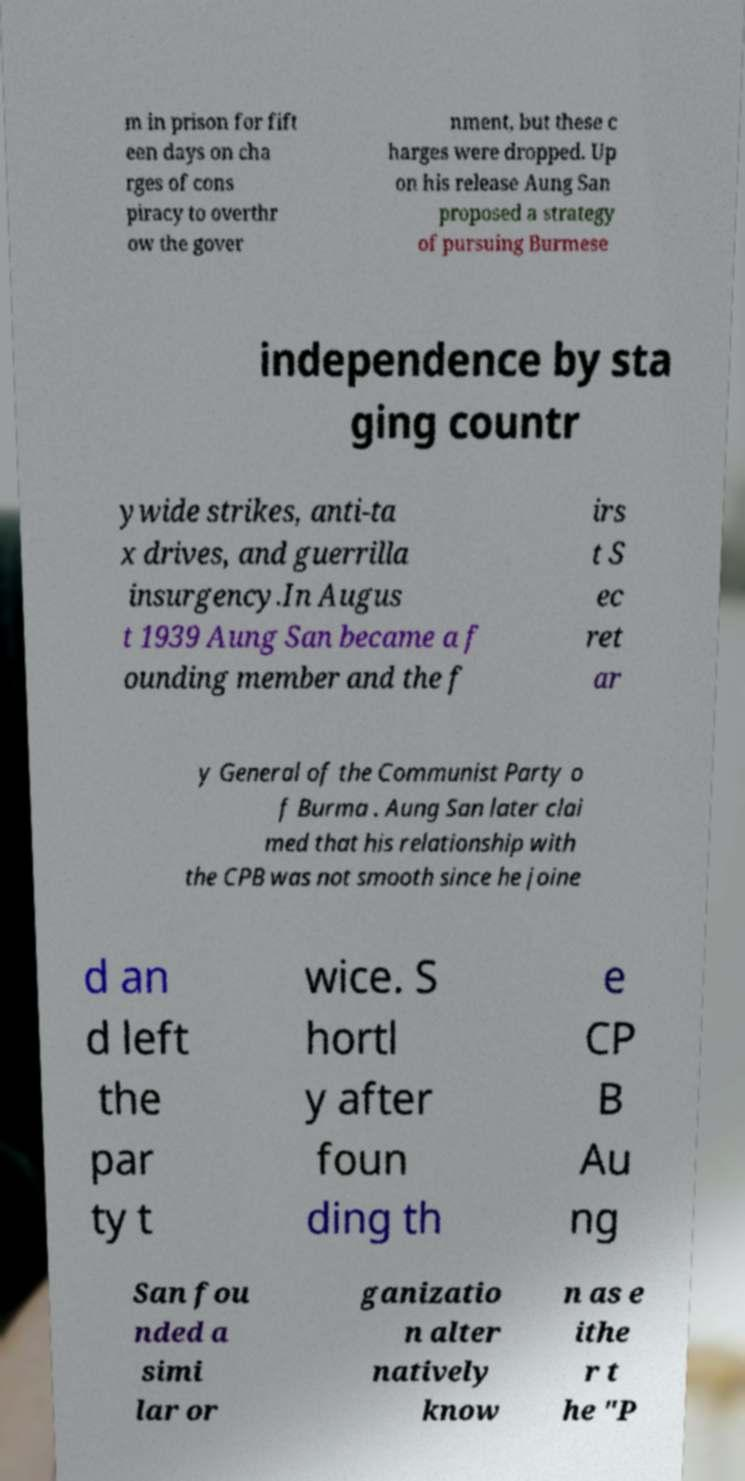What messages or text are displayed in this image? I need them in a readable, typed format. m in prison for fift een days on cha rges of cons piracy to overthr ow the gover nment, but these c harges were dropped. Up on his release Aung San proposed a strategy of pursuing Burmese independence by sta ging countr ywide strikes, anti-ta x drives, and guerrilla insurgency.In Augus t 1939 Aung San became a f ounding member and the f irs t S ec ret ar y General of the Communist Party o f Burma . Aung San later clai med that his relationship with the CPB was not smooth since he joine d an d left the par ty t wice. S hortl y after foun ding th e CP B Au ng San fou nded a simi lar or ganizatio n alter natively know n as e ithe r t he "P 